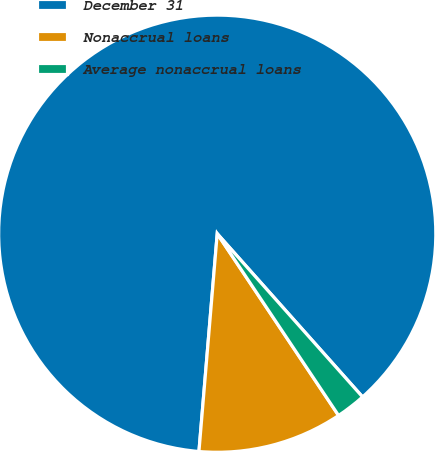<chart> <loc_0><loc_0><loc_500><loc_500><pie_chart><fcel>December 31<fcel>Nonaccrual loans<fcel>Average nonaccrual loans<nl><fcel>87.09%<fcel>10.7%<fcel>2.21%<nl></chart> 